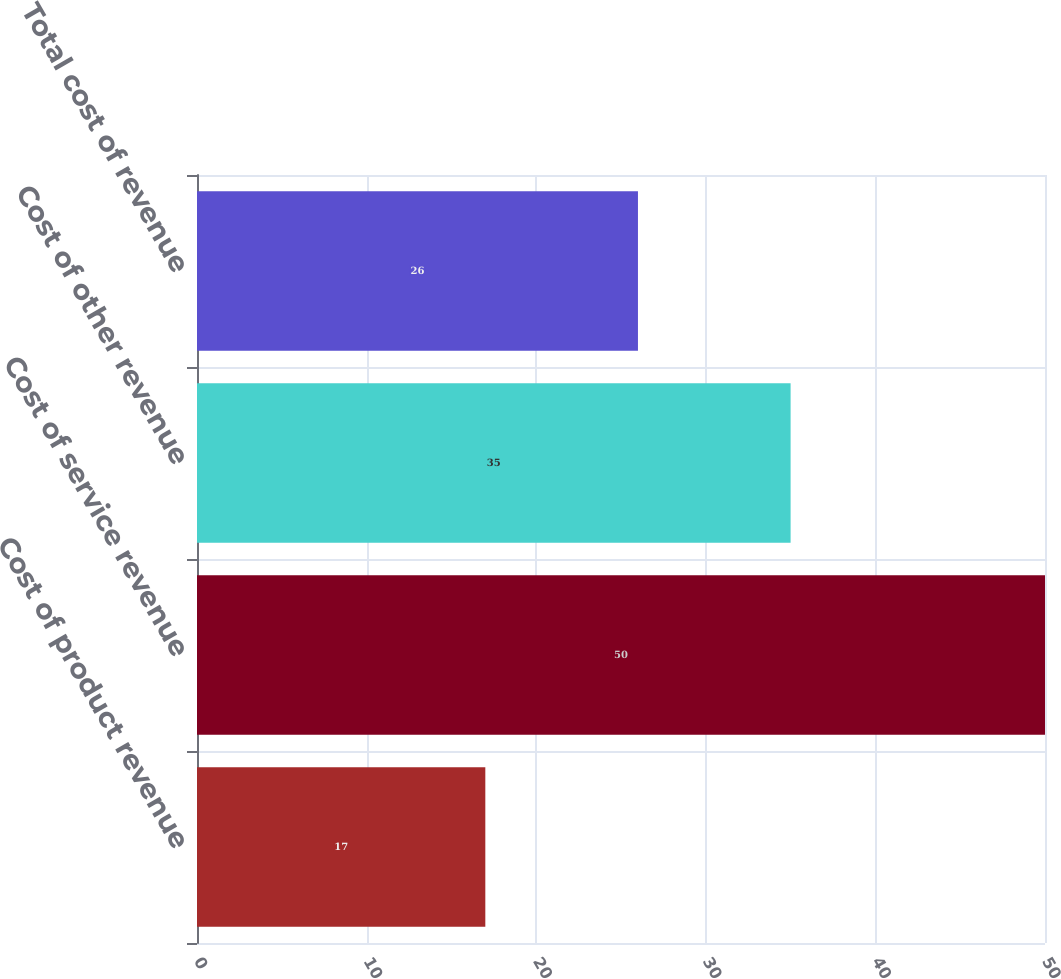<chart> <loc_0><loc_0><loc_500><loc_500><bar_chart><fcel>Cost of product revenue<fcel>Cost of service revenue<fcel>Cost of other revenue<fcel>Total cost of revenue<nl><fcel>17<fcel>50<fcel>35<fcel>26<nl></chart> 